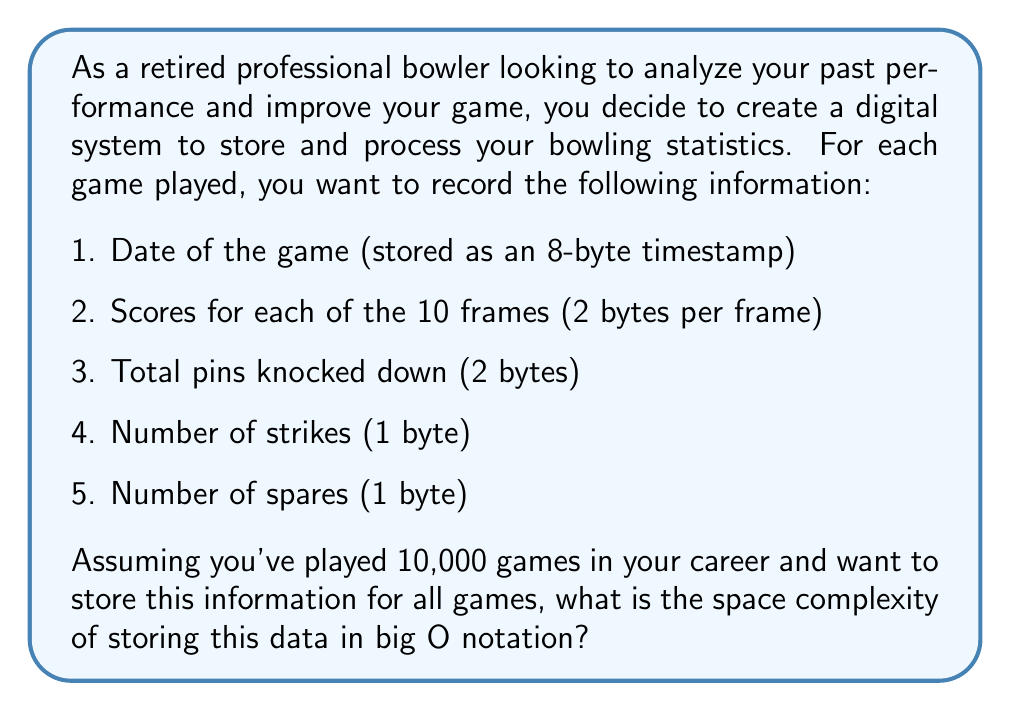What is the answer to this math problem? To determine the space complexity, let's break down the problem step-by-step:

1. Calculate the space required for one game:
   - Date: 8 bytes
   - Scores for 10 frames: $10 \times 2 = 20$ bytes
   - Total pins: 2 bytes
   - Number of strikes: 1 byte
   - Number of spares: 1 byte
   
   Total for one game: $8 + 20 + 2 + 1 + 1 = 32$ bytes

2. For 10,000 games, the total space required would be:
   $32 \text{ bytes} \times 10,000 = 320,000 \text{ bytes}$

3. In big O notation, we're interested in how the space requirements grow with respect to the input size. In this case, the input size is the number of games (n).

4. The space required grows linearly with the number of games. For each additional game, we need a constant amount of extra space (32 bytes).

5. This linear growth is represented in big O notation as $O(n)$, where n is the number of games.

It's important to note that the constant factors (like the 32 bytes per game) are dropped in big O notation, as we're primarily concerned with the growth rate, not the exact values.
Answer: $O(n)$, where n is the number of games. 